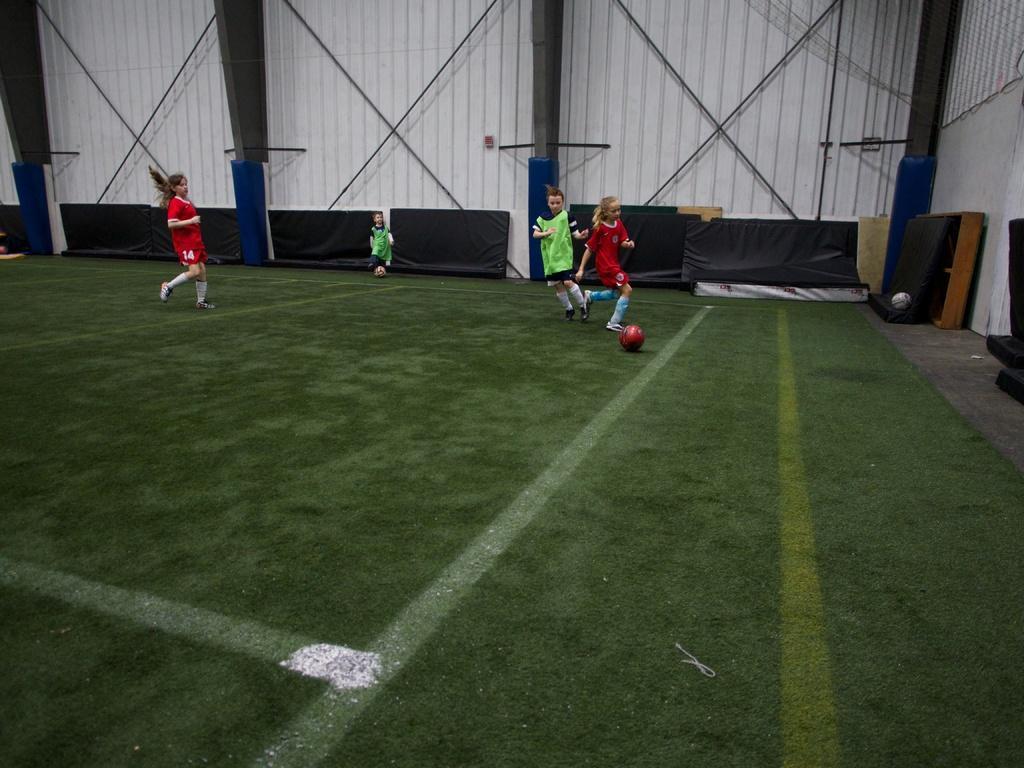Describe this image in one or two sentences. In this image we can see four girls are playing football. Two are wearing red color dress and two are wearing green color dress. The ground is green color. Behind the girls white color sheet wall is there and black color sitting area is present. 